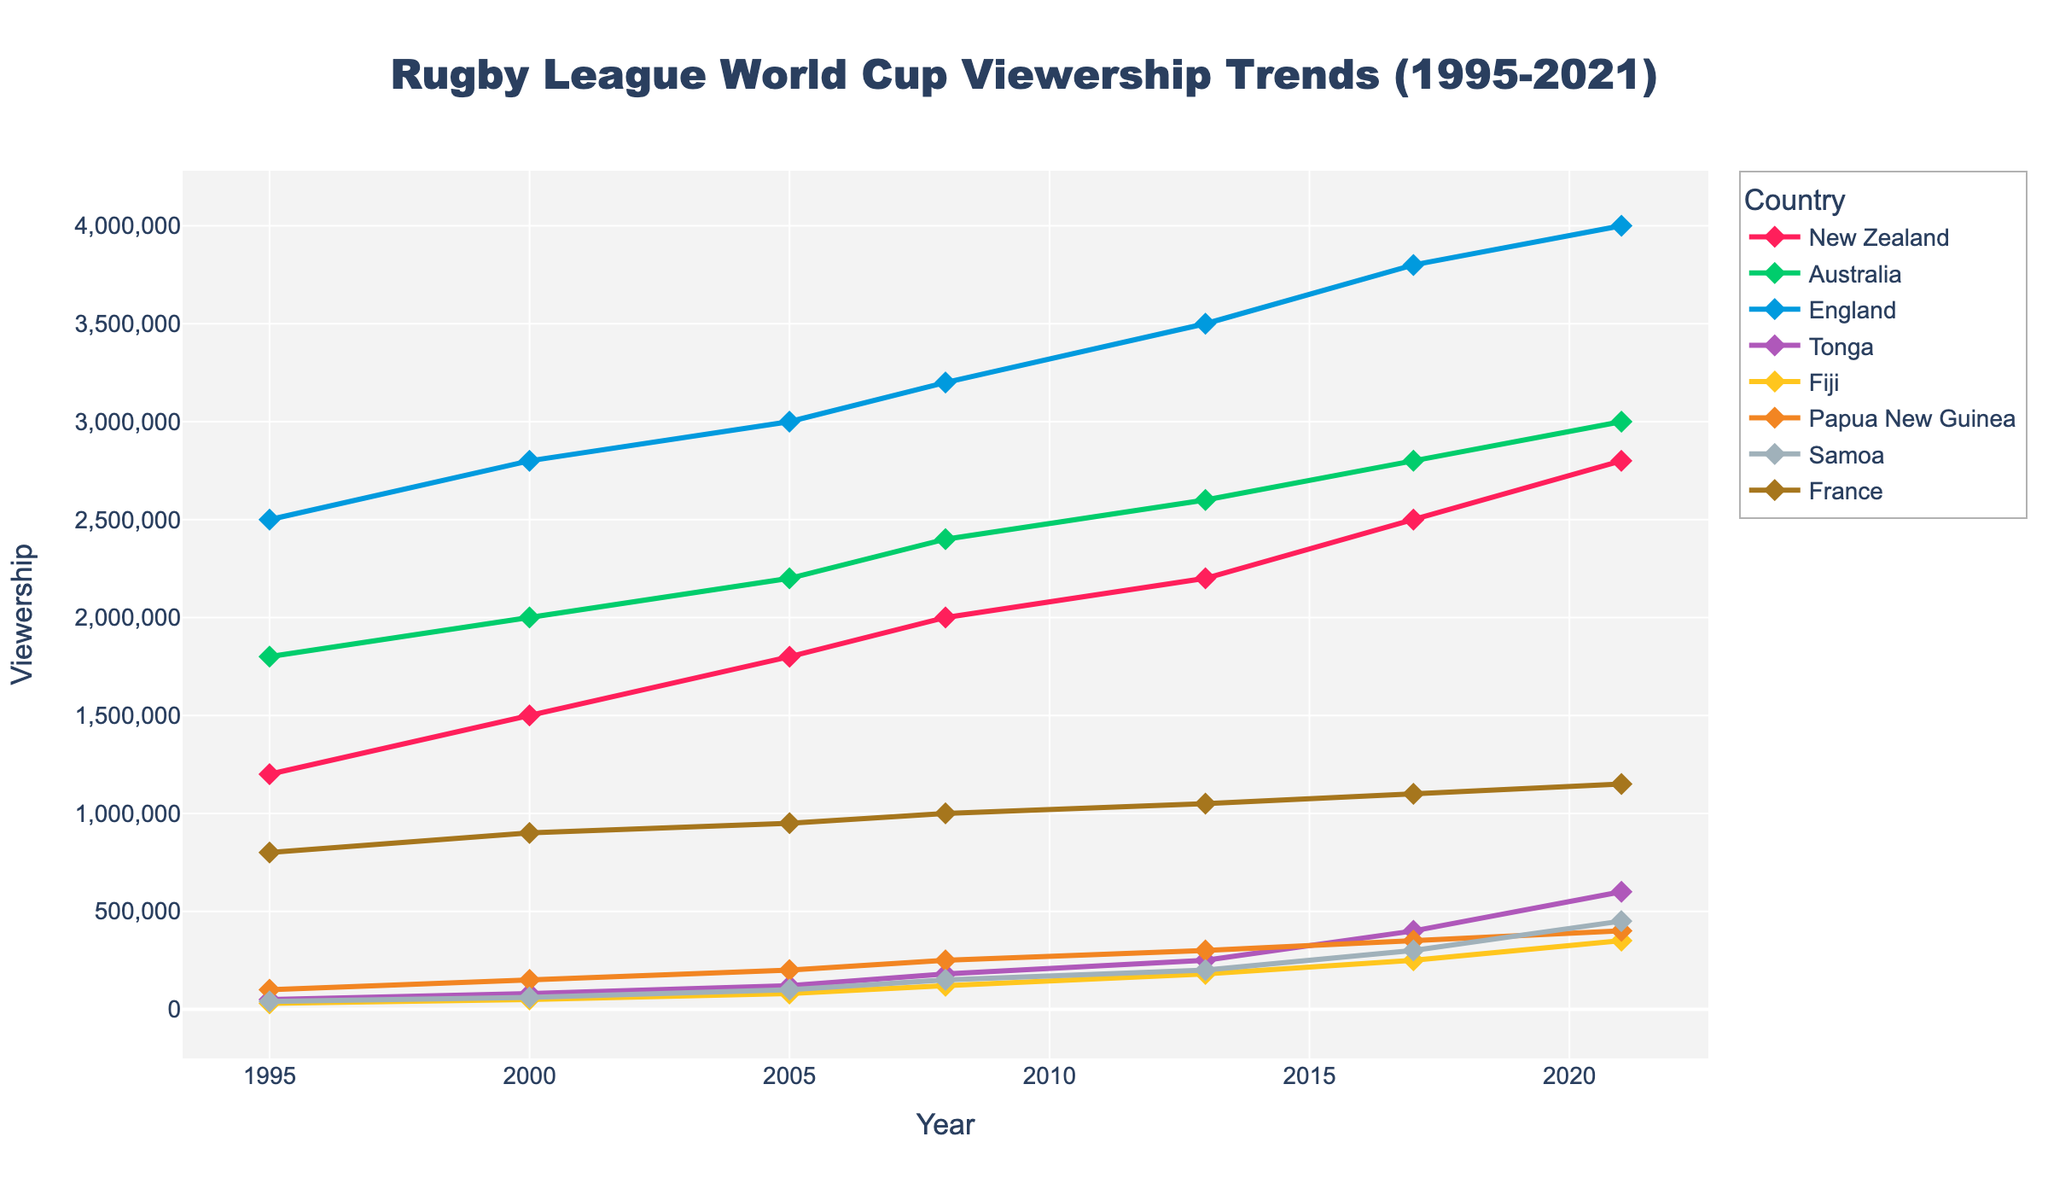Which country had the highest viewership in 2021? In 2021, looking at the plotted lines, the country with the highest y-value corresponds to England.
Answer: England What is the average viewership of New Zealand and Australia in 2008? In 2008, New Zealand's viewership was 2,000,000 and Australia's was 2,400,000. The average is calculated as (2,000,000 + 2,400,000) / 2.
Answer: 2,200,000 Which country showed the most significant increase in viewership from 2017 to 2021? By comparing the increase in y-values from 2017 to 2021, Tonga's viewership increased from 400,000 to 600,000, showing a rise of 200,000. Other countries' increments are smaller.
Answer: Tonga How many countries had a viewership over 1,000,000 in 2013? In 2013, the y-values for New Zealand, Australia, England, and France were all above 1,000,000 as observed from the plot. That makes four countries.
Answer: 4 Compare the viewership trend of Fiji and Samoa. Which one showed a more consistent increase over the years? Fiji's viewership increases steadily from 30,000 in 1995 to 350,000 in 2021, while Samoa shows a more erratic increase, starting at 40,000 in 1995 and reaching 450,000 in 2021. Fiji's trend is more consistent.
Answer: Fiji What were the viewership numbers of France in 2000 and 2021, and what is the difference? France had 900,000 viewers in 2000 and 1,150,000 viewers in 2021. The difference is 1,150,000 - 900,000.
Answer: 250,000 Which country had the lowest viewership in 1995, and what was the value? In 1995, Tonga had the lowest viewership, which was 50,000.
Answer: Tonga Between 1995 and 2021, which country's viewership increased the most? By observing the starting and ending points of the lines, New Zealand's viewership increased from 1,200,000 in 1995 to 2,800,000 in 2021, making it an increase of 1,600,000. This is the highest increase among all countries.
Answer: New Zealand Which three countries had the viewership above 3,000,000 for the first time in 2017? In 2017, the viewership for New Zealand, Australia, and England went above 3,000,000 as indicated by the lines crossing the 3,000,000 mark.
Answer: New Zealand, Australia, England What is the total viewership for Tonga across all the recorded years? Summing the viewership numbers for Tonga from all years: 50,000 + 80,000 + 120,000 + 180,000 + 250,000 + 400,000 + 600,000 = 1,680,000.
Answer: 1,680,000 